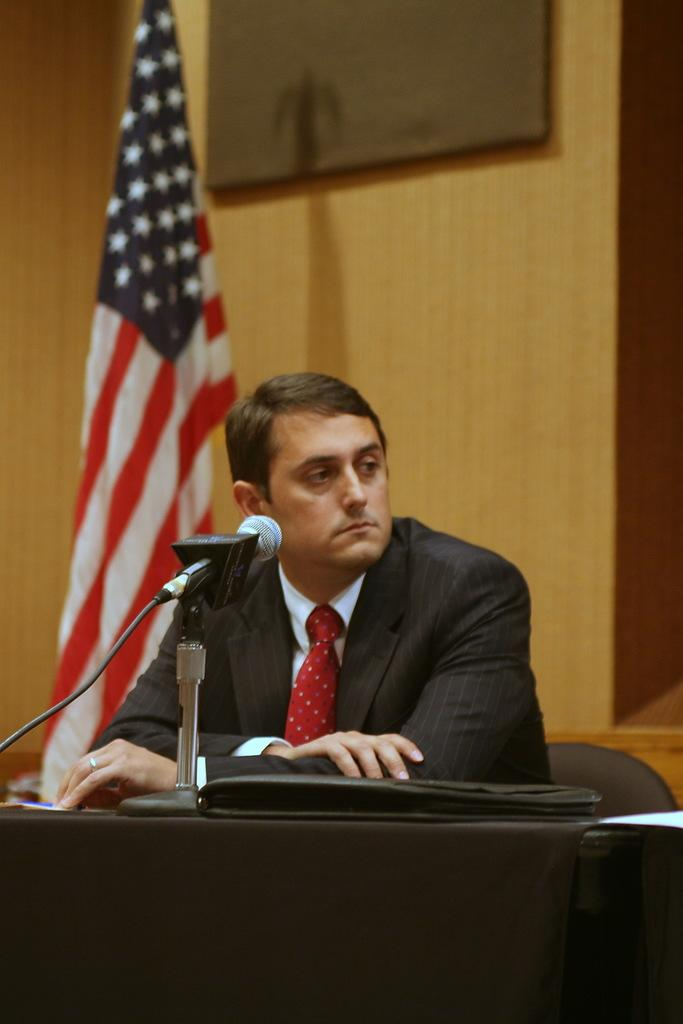What is the man in the image doing? The man is sitting on a chair in the image. What can be seen in the background of the image? There is a flag in the background of the image. What object is placed on the table in the image? A mic is placed on a table in the image. What type of degree is the man holding in the image? There is no degree visible in the image; the man is simply sitting on a chair. 